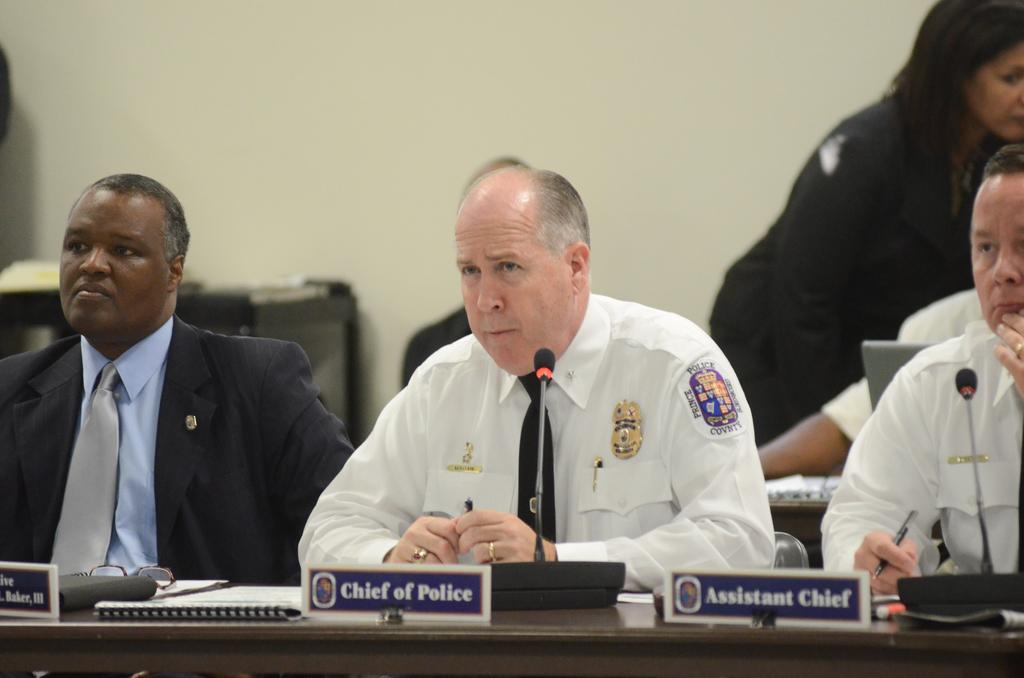Who or what can be seen in the image? There are people in the image. What are the name boards in front of the people used for? The name boards in front of the people are likely used for identification purposes. What else is present in front of the people? There are objects in front of the people, but their specific nature is not mentioned in the facts. What can be seen in the background of the image? There is a wall visible in the background of the image. What type of stitch is being used to sew the dad's shirt in the image? There is no dad or shirt visible in the image, so it is not possible to determine the type of stitch being used. 